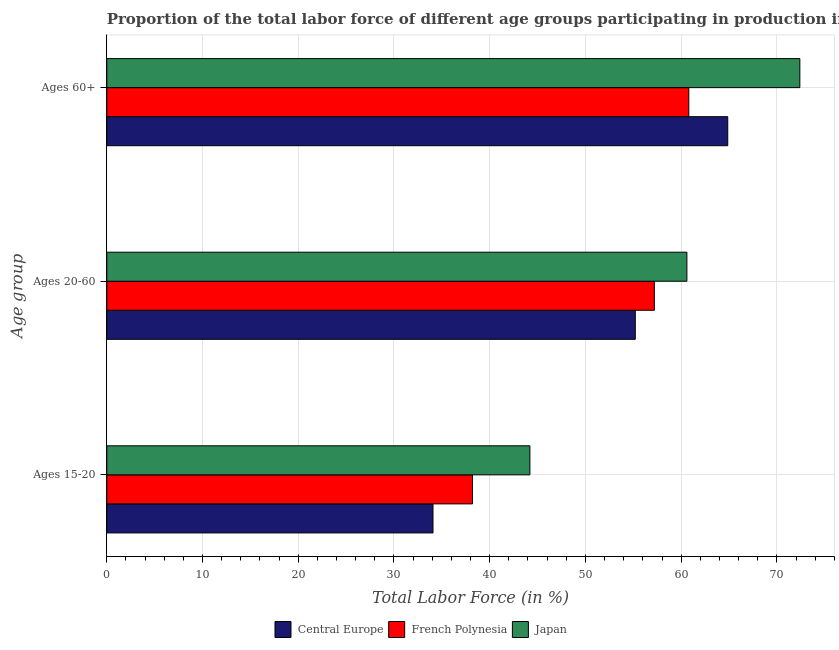How many different coloured bars are there?
Your answer should be compact. 3. How many bars are there on the 3rd tick from the bottom?
Ensure brevity in your answer.  3. What is the label of the 3rd group of bars from the top?
Keep it short and to the point. Ages 15-20. What is the percentage of labor force above age 60 in French Polynesia?
Keep it short and to the point. 60.8. Across all countries, what is the maximum percentage of labor force within the age group 15-20?
Your response must be concise. 44.2. Across all countries, what is the minimum percentage of labor force within the age group 15-20?
Your answer should be compact. 34.08. In which country was the percentage of labor force within the age group 20-60 minimum?
Offer a terse response. Central Europe. What is the total percentage of labor force above age 60 in the graph?
Offer a very short reply. 198.07. What is the difference between the percentage of labor force above age 60 in Central Europe and that in Japan?
Keep it short and to the point. -7.53. What is the difference between the percentage of labor force within the age group 20-60 in Japan and the percentage of labor force above age 60 in French Polynesia?
Your answer should be compact. -0.2. What is the average percentage of labor force above age 60 per country?
Your answer should be compact. 66.02. What is the difference between the percentage of labor force above age 60 and percentage of labor force within the age group 20-60 in Central Europe?
Make the answer very short. 9.66. In how many countries, is the percentage of labor force above age 60 greater than 42 %?
Your response must be concise. 3. What is the ratio of the percentage of labor force within the age group 20-60 in Japan to that in French Polynesia?
Your answer should be compact. 1.06. Is the difference between the percentage of labor force within the age group 20-60 in French Polynesia and Central Europe greater than the difference between the percentage of labor force above age 60 in French Polynesia and Central Europe?
Ensure brevity in your answer.  Yes. What is the difference between the highest and the second highest percentage of labor force within the age group 20-60?
Your answer should be compact. 3.4. What is the difference between the highest and the lowest percentage of labor force within the age group 20-60?
Ensure brevity in your answer.  5.39. In how many countries, is the percentage of labor force above age 60 greater than the average percentage of labor force above age 60 taken over all countries?
Your response must be concise. 1. What does the 2nd bar from the top in Ages 15-20 represents?
Your answer should be compact. French Polynesia. What does the 1st bar from the bottom in Ages 15-20 represents?
Your answer should be very brief. Central Europe. Is it the case that in every country, the sum of the percentage of labor force within the age group 15-20 and percentage of labor force within the age group 20-60 is greater than the percentage of labor force above age 60?
Offer a very short reply. Yes. How many bars are there?
Keep it short and to the point. 9. Are all the bars in the graph horizontal?
Your response must be concise. Yes. What is the difference between two consecutive major ticks on the X-axis?
Your response must be concise. 10. Where does the legend appear in the graph?
Offer a very short reply. Bottom center. How many legend labels are there?
Offer a terse response. 3. How are the legend labels stacked?
Your answer should be very brief. Horizontal. What is the title of the graph?
Ensure brevity in your answer.  Proportion of the total labor force of different age groups participating in production in 2004. Does "Cuba" appear as one of the legend labels in the graph?
Offer a terse response. No. What is the label or title of the X-axis?
Give a very brief answer. Total Labor Force (in %). What is the label or title of the Y-axis?
Provide a succinct answer. Age group. What is the Total Labor Force (in %) in Central Europe in Ages 15-20?
Provide a short and direct response. 34.08. What is the Total Labor Force (in %) of French Polynesia in Ages 15-20?
Make the answer very short. 38.2. What is the Total Labor Force (in %) of Japan in Ages 15-20?
Offer a terse response. 44.2. What is the Total Labor Force (in %) in Central Europe in Ages 20-60?
Keep it short and to the point. 55.21. What is the Total Labor Force (in %) in French Polynesia in Ages 20-60?
Offer a terse response. 57.2. What is the Total Labor Force (in %) in Japan in Ages 20-60?
Keep it short and to the point. 60.6. What is the Total Labor Force (in %) of Central Europe in Ages 60+?
Ensure brevity in your answer.  64.87. What is the Total Labor Force (in %) of French Polynesia in Ages 60+?
Provide a short and direct response. 60.8. What is the Total Labor Force (in %) in Japan in Ages 60+?
Give a very brief answer. 72.4. Across all Age group, what is the maximum Total Labor Force (in %) of Central Europe?
Keep it short and to the point. 64.87. Across all Age group, what is the maximum Total Labor Force (in %) in French Polynesia?
Ensure brevity in your answer.  60.8. Across all Age group, what is the maximum Total Labor Force (in %) in Japan?
Your response must be concise. 72.4. Across all Age group, what is the minimum Total Labor Force (in %) of Central Europe?
Your response must be concise. 34.08. Across all Age group, what is the minimum Total Labor Force (in %) in French Polynesia?
Provide a short and direct response. 38.2. Across all Age group, what is the minimum Total Labor Force (in %) of Japan?
Your answer should be very brief. 44.2. What is the total Total Labor Force (in %) of Central Europe in the graph?
Provide a short and direct response. 154.16. What is the total Total Labor Force (in %) in French Polynesia in the graph?
Ensure brevity in your answer.  156.2. What is the total Total Labor Force (in %) in Japan in the graph?
Your answer should be compact. 177.2. What is the difference between the Total Labor Force (in %) in Central Europe in Ages 15-20 and that in Ages 20-60?
Your answer should be compact. -21.13. What is the difference between the Total Labor Force (in %) of French Polynesia in Ages 15-20 and that in Ages 20-60?
Offer a terse response. -19. What is the difference between the Total Labor Force (in %) of Japan in Ages 15-20 and that in Ages 20-60?
Your answer should be very brief. -16.4. What is the difference between the Total Labor Force (in %) of Central Europe in Ages 15-20 and that in Ages 60+?
Give a very brief answer. -30.79. What is the difference between the Total Labor Force (in %) of French Polynesia in Ages 15-20 and that in Ages 60+?
Make the answer very short. -22.6. What is the difference between the Total Labor Force (in %) in Japan in Ages 15-20 and that in Ages 60+?
Your answer should be compact. -28.2. What is the difference between the Total Labor Force (in %) of Central Europe in Ages 20-60 and that in Ages 60+?
Your response must be concise. -9.66. What is the difference between the Total Labor Force (in %) in French Polynesia in Ages 20-60 and that in Ages 60+?
Give a very brief answer. -3.6. What is the difference between the Total Labor Force (in %) in Japan in Ages 20-60 and that in Ages 60+?
Provide a succinct answer. -11.8. What is the difference between the Total Labor Force (in %) of Central Europe in Ages 15-20 and the Total Labor Force (in %) of French Polynesia in Ages 20-60?
Offer a terse response. -23.12. What is the difference between the Total Labor Force (in %) of Central Europe in Ages 15-20 and the Total Labor Force (in %) of Japan in Ages 20-60?
Give a very brief answer. -26.52. What is the difference between the Total Labor Force (in %) of French Polynesia in Ages 15-20 and the Total Labor Force (in %) of Japan in Ages 20-60?
Your response must be concise. -22.4. What is the difference between the Total Labor Force (in %) in Central Europe in Ages 15-20 and the Total Labor Force (in %) in French Polynesia in Ages 60+?
Give a very brief answer. -26.72. What is the difference between the Total Labor Force (in %) in Central Europe in Ages 15-20 and the Total Labor Force (in %) in Japan in Ages 60+?
Offer a very short reply. -38.32. What is the difference between the Total Labor Force (in %) of French Polynesia in Ages 15-20 and the Total Labor Force (in %) of Japan in Ages 60+?
Your answer should be very brief. -34.2. What is the difference between the Total Labor Force (in %) of Central Europe in Ages 20-60 and the Total Labor Force (in %) of French Polynesia in Ages 60+?
Keep it short and to the point. -5.59. What is the difference between the Total Labor Force (in %) in Central Europe in Ages 20-60 and the Total Labor Force (in %) in Japan in Ages 60+?
Your response must be concise. -17.19. What is the difference between the Total Labor Force (in %) of French Polynesia in Ages 20-60 and the Total Labor Force (in %) of Japan in Ages 60+?
Make the answer very short. -15.2. What is the average Total Labor Force (in %) of Central Europe per Age group?
Provide a succinct answer. 51.39. What is the average Total Labor Force (in %) in French Polynesia per Age group?
Provide a succinct answer. 52.07. What is the average Total Labor Force (in %) in Japan per Age group?
Your response must be concise. 59.07. What is the difference between the Total Labor Force (in %) of Central Europe and Total Labor Force (in %) of French Polynesia in Ages 15-20?
Your answer should be compact. -4.12. What is the difference between the Total Labor Force (in %) of Central Europe and Total Labor Force (in %) of Japan in Ages 15-20?
Your response must be concise. -10.12. What is the difference between the Total Labor Force (in %) of Central Europe and Total Labor Force (in %) of French Polynesia in Ages 20-60?
Your response must be concise. -1.99. What is the difference between the Total Labor Force (in %) in Central Europe and Total Labor Force (in %) in Japan in Ages 20-60?
Make the answer very short. -5.39. What is the difference between the Total Labor Force (in %) of Central Europe and Total Labor Force (in %) of French Polynesia in Ages 60+?
Provide a short and direct response. 4.07. What is the difference between the Total Labor Force (in %) of Central Europe and Total Labor Force (in %) of Japan in Ages 60+?
Your response must be concise. -7.53. What is the ratio of the Total Labor Force (in %) of Central Europe in Ages 15-20 to that in Ages 20-60?
Your answer should be compact. 0.62. What is the ratio of the Total Labor Force (in %) of French Polynesia in Ages 15-20 to that in Ages 20-60?
Give a very brief answer. 0.67. What is the ratio of the Total Labor Force (in %) of Japan in Ages 15-20 to that in Ages 20-60?
Offer a terse response. 0.73. What is the ratio of the Total Labor Force (in %) in Central Europe in Ages 15-20 to that in Ages 60+?
Make the answer very short. 0.53. What is the ratio of the Total Labor Force (in %) in French Polynesia in Ages 15-20 to that in Ages 60+?
Offer a very short reply. 0.63. What is the ratio of the Total Labor Force (in %) of Japan in Ages 15-20 to that in Ages 60+?
Make the answer very short. 0.61. What is the ratio of the Total Labor Force (in %) of Central Europe in Ages 20-60 to that in Ages 60+?
Offer a very short reply. 0.85. What is the ratio of the Total Labor Force (in %) in French Polynesia in Ages 20-60 to that in Ages 60+?
Your answer should be very brief. 0.94. What is the ratio of the Total Labor Force (in %) in Japan in Ages 20-60 to that in Ages 60+?
Keep it short and to the point. 0.84. What is the difference between the highest and the second highest Total Labor Force (in %) of Central Europe?
Give a very brief answer. 9.66. What is the difference between the highest and the lowest Total Labor Force (in %) in Central Europe?
Offer a terse response. 30.79. What is the difference between the highest and the lowest Total Labor Force (in %) of French Polynesia?
Provide a short and direct response. 22.6. What is the difference between the highest and the lowest Total Labor Force (in %) of Japan?
Your answer should be very brief. 28.2. 